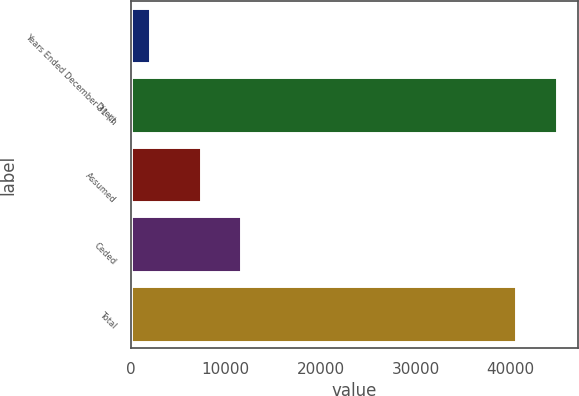Convert chart to OTSL. <chart><loc_0><loc_0><loc_500><loc_500><bar_chart><fcel>Years Ended December 31 (in<fcel>Direct<fcel>Assumed<fcel>Ceded<fcel>Total<nl><fcel>2004<fcel>44891.8<fcel>7354<fcel>11622.8<fcel>40623<nl></chart> 